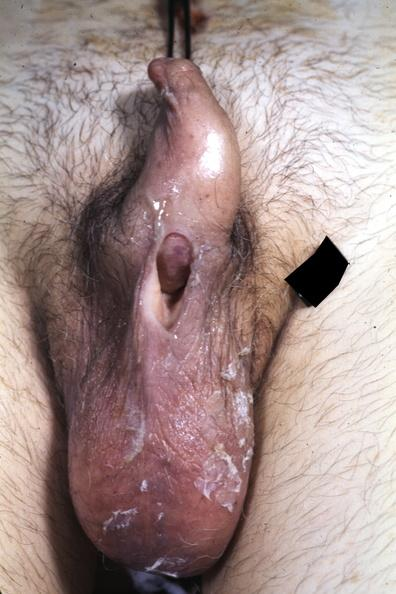what is present?
Answer the question using a single word or phrase. Hypospadias 